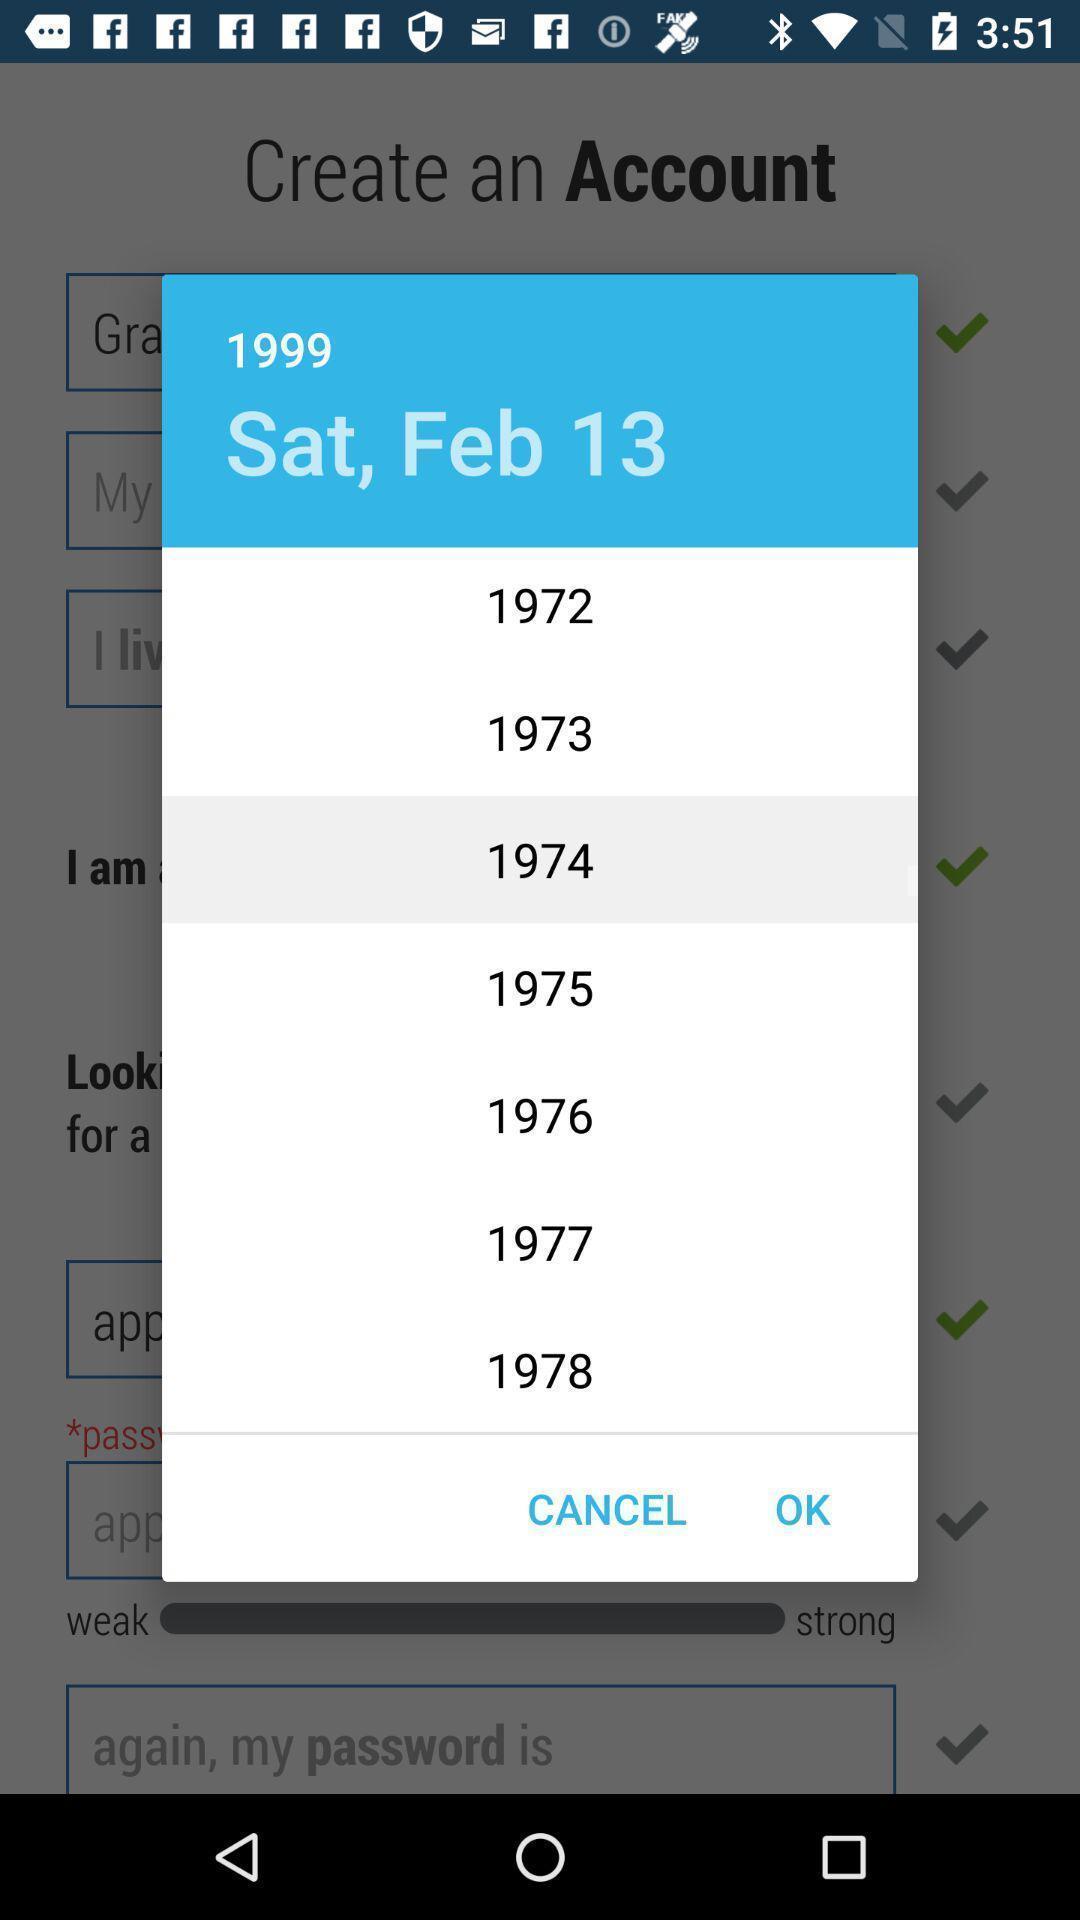What is the overall content of this screenshot? Pop-up showing the date with list of years. 